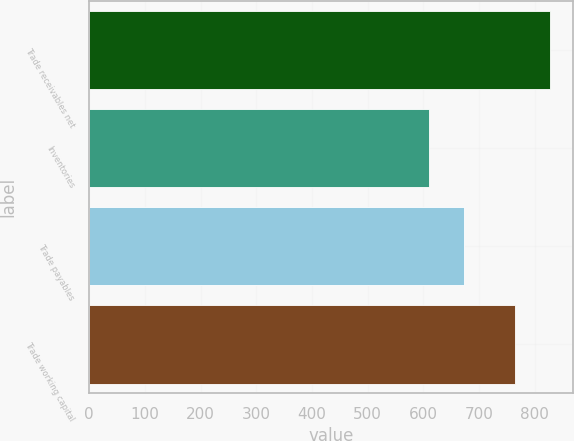<chart> <loc_0><loc_0><loc_500><loc_500><bar_chart><fcel>Trade receivables net<fcel>Inventories<fcel>Trade payables<fcel>Trade working capital<nl><fcel>827<fcel>610<fcel>673<fcel>764<nl></chart> 